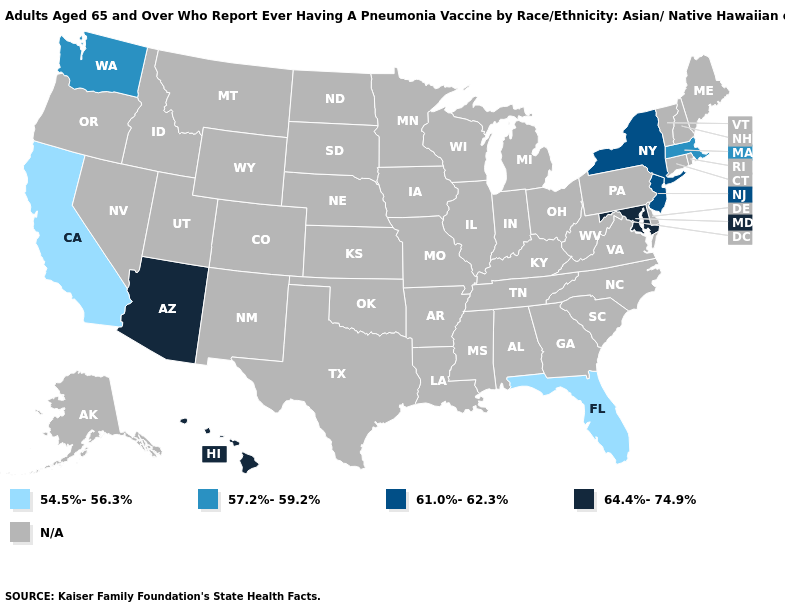What is the value of North Carolina?
Write a very short answer. N/A. What is the lowest value in the USA?
Give a very brief answer. 54.5%-56.3%. How many symbols are there in the legend?
Answer briefly. 5. Does the map have missing data?
Answer briefly. Yes. Among the states that border Rhode Island , which have the lowest value?
Be succinct. Massachusetts. Which states hav the highest value in the South?
Concise answer only. Maryland. Does the first symbol in the legend represent the smallest category?
Answer briefly. Yes. Which states have the lowest value in the USA?
Be succinct. California, Florida. Is the legend a continuous bar?
Answer briefly. No. What is the value of South Dakota?
Concise answer only. N/A. Among the states that border Vermont , does Massachusetts have the highest value?
Short answer required. No. 